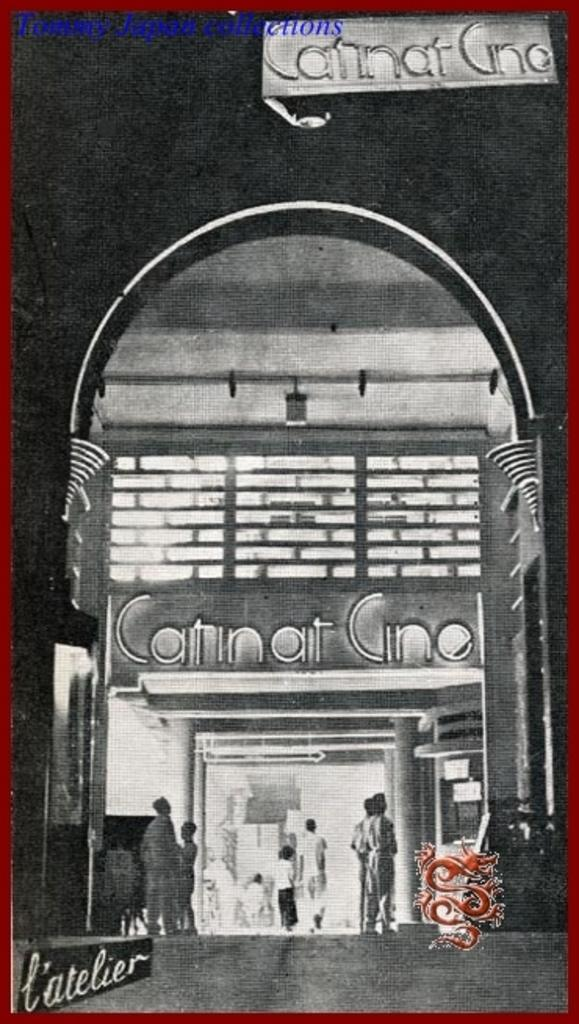What type of image is being described? The image is a portrait. Who or what is the focus of the portrait? The portrait features people. Where are the people located in the image? The people are in front of a building. What architectural feature can be seen at the entrance of the building? There is an arch at the entrance of the building. What is the caption written below the image? There is no caption provided in the image, so we cannot determine what it might say. 